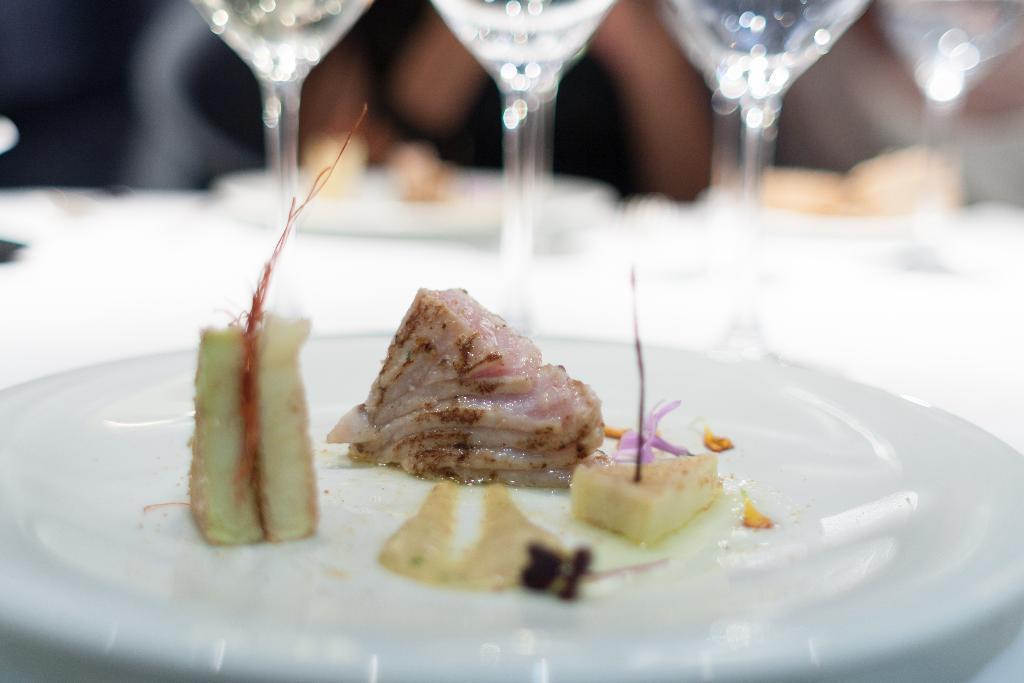Describe this image in one or two sentences. In this image we can see there is a plate on the table which is served with food beside that there are so many glasses. 